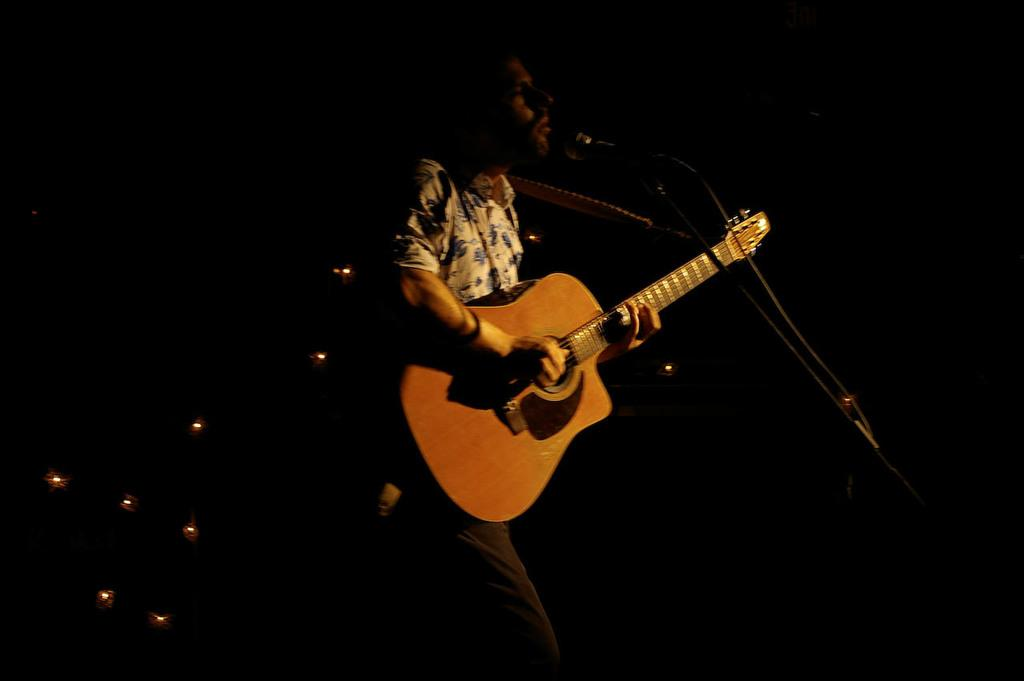What is the person in the image doing? The person is singing and playing a guitar. What object is the person holding while singing? The person is holding a microphone. What can be seen in the background of the image? There are lights visible in the background. What type of ball is being traded in the image? There is no ball or trade activity present in the image. Is there a tent visible in the image? No, there is no tent present in the image. 